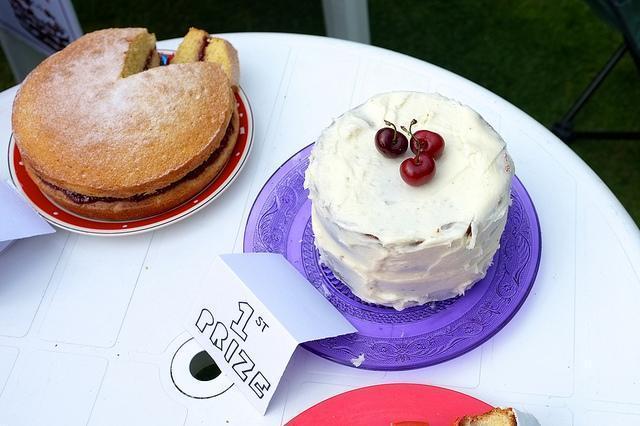How many slices are cut from the cake on the left?
Give a very brief answer. 1. How many cakes are pictured?
Give a very brief answer. 2. How many cakes can be seen?
Give a very brief answer. 2. How many people in the audience are wearing a yellow jacket?
Give a very brief answer. 0. 